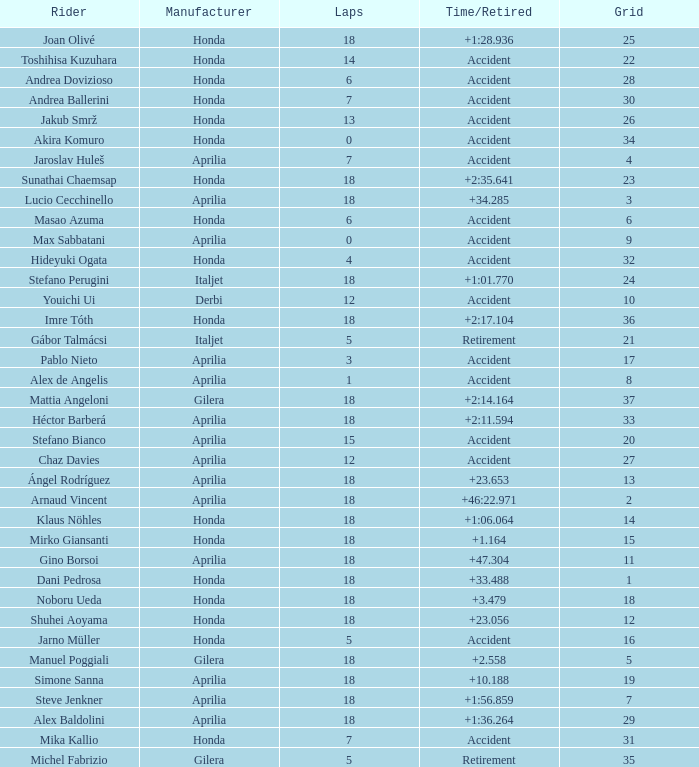Help me parse the entirety of this table. {'header': ['Rider', 'Manufacturer', 'Laps', 'Time/Retired', 'Grid'], 'rows': [['Joan Olivé', 'Honda', '18', '+1:28.936', '25'], ['Toshihisa Kuzuhara', 'Honda', '14', 'Accident', '22'], ['Andrea Dovizioso', 'Honda', '6', 'Accident', '28'], ['Andrea Ballerini', 'Honda', '7', 'Accident', '30'], ['Jakub Smrž', 'Honda', '13', 'Accident', '26'], ['Akira Komuro', 'Honda', '0', 'Accident', '34'], ['Jaroslav Huleš', 'Aprilia', '7', 'Accident', '4'], ['Sunathai Chaemsap', 'Honda', '18', '+2:35.641', '23'], ['Lucio Cecchinello', 'Aprilia', '18', '+34.285', '3'], ['Masao Azuma', 'Honda', '6', 'Accident', '6'], ['Max Sabbatani', 'Aprilia', '0', 'Accident', '9'], ['Hideyuki Ogata', 'Honda', '4', 'Accident', '32'], ['Stefano Perugini', 'Italjet', '18', '+1:01.770', '24'], ['Youichi Ui', 'Derbi', '12', 'Accident', '10'], ['Imre Tóth', 'Honda', '18', '+2:17.104', '36'], ['Gábor Talmácsi', 'Italjet', '5', 'Retirement', '21'], ['Pablo Nieto', 'Aprilia', '3', 'Accident', '17'], ['Alex de Angelis', 'Aprilia', '1', 'Accident', '8'], ['Mattia Angeloni', 'Gilera', '18', '+2:14.164', '37'], ['Héctor Barberá', 'Aprilia', '18', '+2:11.594', '33'], ['Stefano Bianco', 'Aprilia', '15', 'Accident', '20'], ['Chaz Davies', 'Aprilia', '12', 'Accident', '27'], ['Ángel Rodríguez', 'Aprilia', '18', '+23.653', '13'], ['Arnaud Vincent', 'Aprilia', '18', '+46:22.971', '2'], ['Klaus Nöhles', 'Honda', '18', '+1:06.064', '14'], ['Mirko Giansanti', 'Honda', '18', '+1.164', '15'], ['Gino Borsoi', 'Aprilia', '18', '+47.304', '11'], ['Dani Pedrosa', 'Honda', '18', '+33.488', '1'], ['Noboru Ueda', 'Honda', '18', '+3.479', '18'], ['Shuhei Aoyama', 'Honda', '18', '+23.056', '12'], ['Jarno Müller', 'Honda', '5', 'Accident', '16'], ['Manuel Poggiali', 'Gilera', '18', '+2.558', '5'], ['Simone Sanna', 'Aprilia', '18', '+10.188', '19'], ['Steve Jenkner', 'Aprilia', '18', '+1:56.859', '7'], ['Alex Baldolini', 'Aprilia', '18', '+1:36.264', '29'], ['Mika Kallio', 'Honda', '7', 'Accident', '31'], ['Michel Fabrizio', 'Gilera', '5', 'Retirement', '35']]} Who is the rider with less than 15 laps, more than 32 grids, and an accident time/retired? Akira Komuro. 